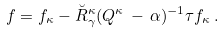<formula> <loc_0><loc_0><loc_500><loc_500>f = f _ { \kappa } - \breve { R } _ { \gamma } ^ { \kappa } ( Q ^ { \kappa } \, - \, \alpha ) ^ { - 1 } \tau f _ { \kappa } \, .</formula> 